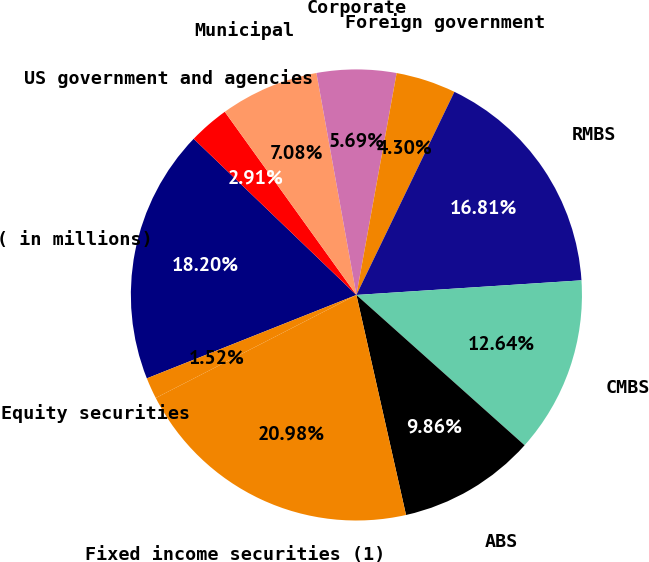Convert chart to OTSL. <chart><loc_0><loc_0><loc_500><loc_500><pie_chart><fcel>( in millions)<fcel>US government and agencies<fcel>Municipal<fcel>Corporate<fcel>Foreign government<fcel>RMBS<fcel>CMBS<fcel>ABS<fcel>Fixed income securities (1)<fcel>Equity securities<nl><fcel>18.2%<fcel>2.91%<fcel>7.08%<fcel>5.69%<fcel>4.3%<fcel>16.81%<fcel>12.64%<fcel>9.86%<fcel>20.98%<fcel>1.52%<nl></chart> 